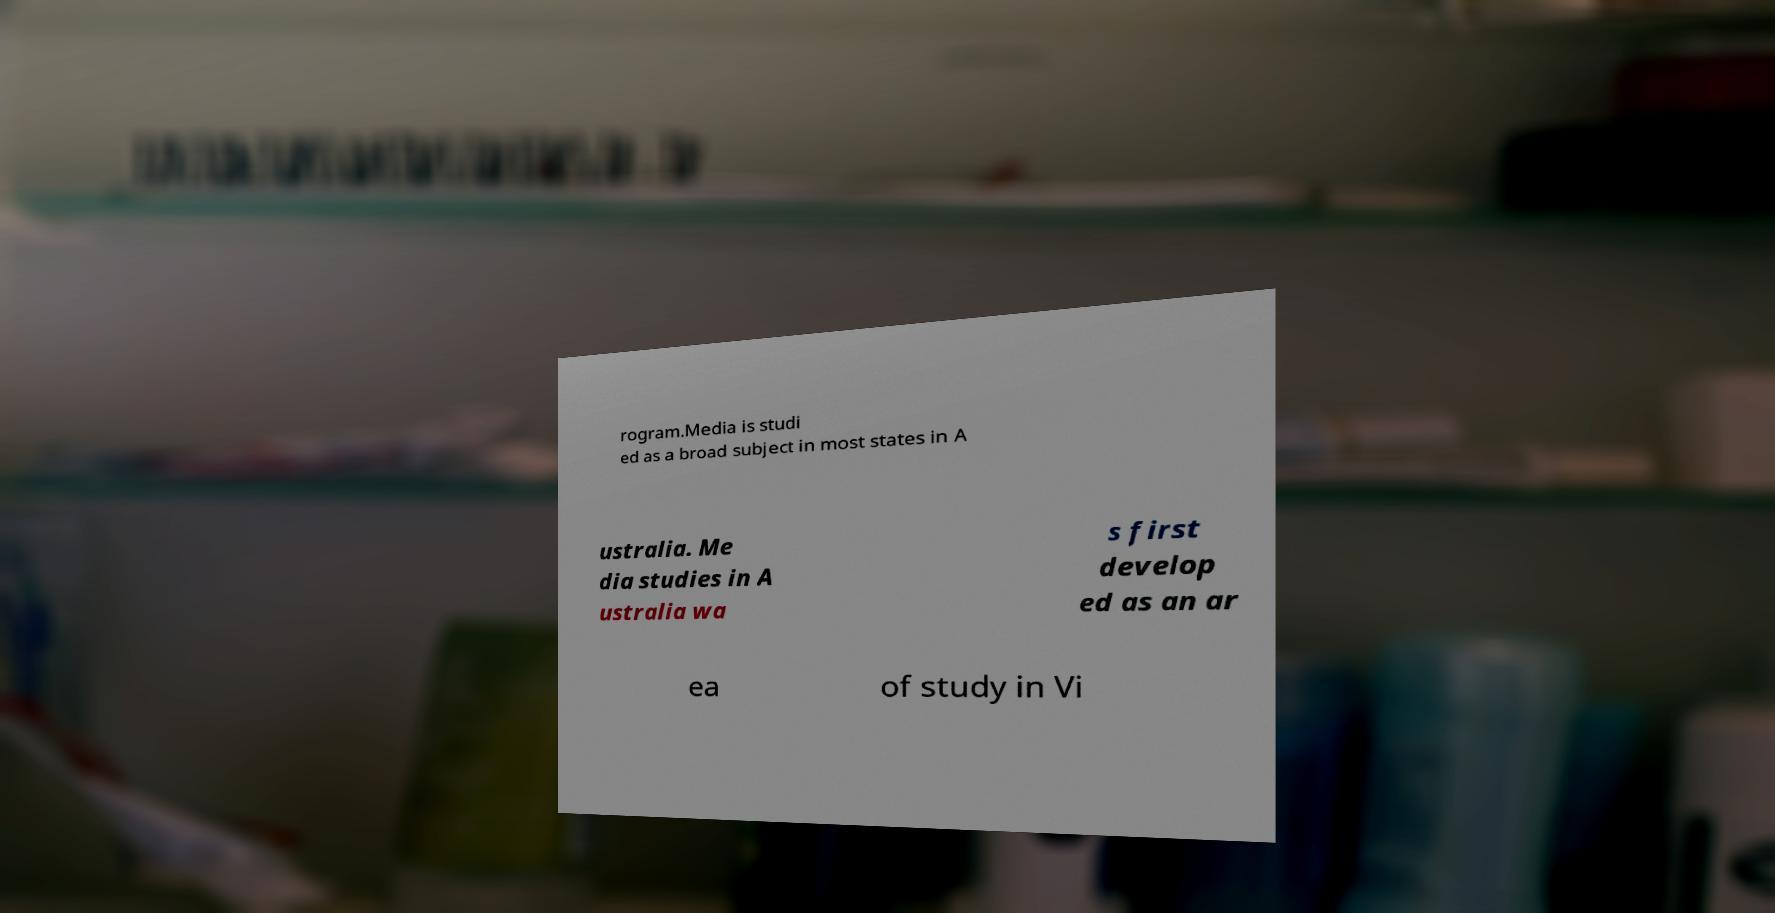Could you assist in decoding the text presented in this image and type it out clearly? rogram.Media is studi ed as a broad subject in most states in A ustralia. Me dia studies in A ustralia wa s first develop ed as an ar ea of study in Vi 